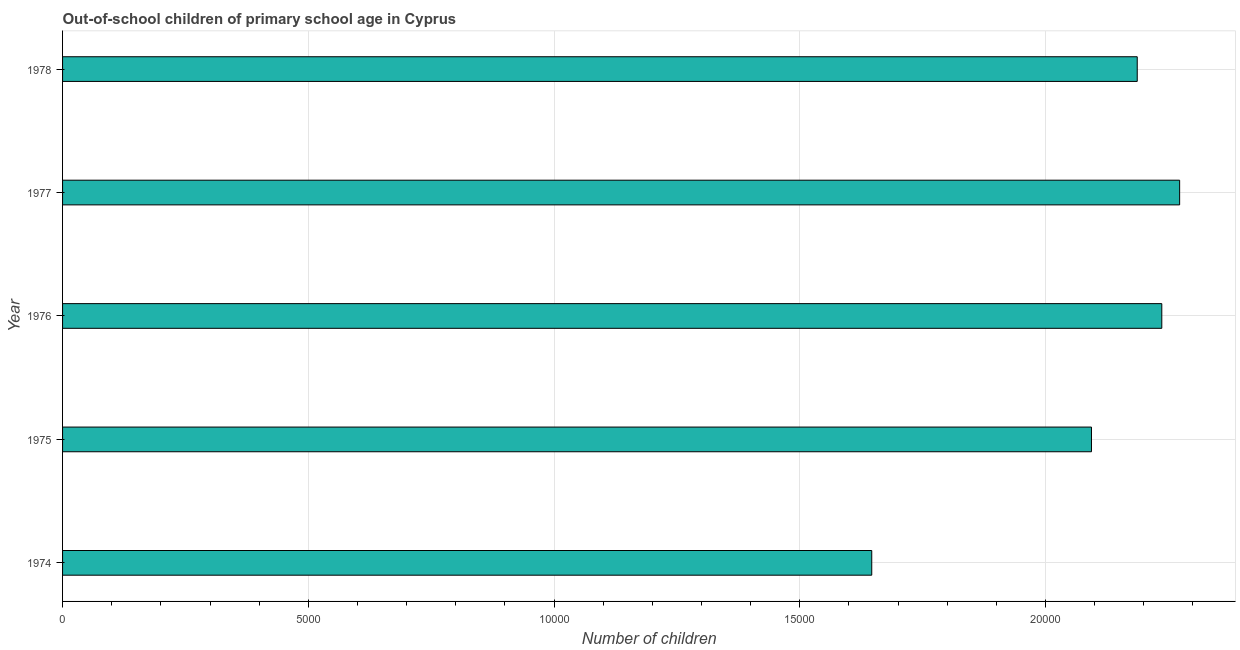What is the title of the graph?
Make the answer very short. Out-of-school children of primary school age in Cyprus. What is the label or title of the X-axis?
Give a very brief answer. Number of children. What is the number of out-of-school children in 1978?
Keep it short and to the point. 2.19e+04. Across all years, what is the maximum number of out-of-school children?
Keep it short and to the point. 2.27e+04. Across all years, what is the minimum number of out-of-school children?
Provide a short and direct response. 1.65e+04. In which year was the number of out-of-school children minimum?
Your answer should be very brief. 1974. What is the sum of the number of out-of-school children?
Offer a terse response. 1.04e+05. What is the difference between the number of out-of-school children in 1974 and 1975?
Your answer should be compact. -4471. What is the average number of out-of-school children per year?
Offer a terse response. 2.09e+04. What is the median number of out-of-school children?
Provide a succinct answer. 2.19e+04. Do a majority of the years between 1974 and 1978 (inclusive) have number of out-of-school children greater than 11000 ?
Your response must be concise. Yes. What is the ratio of the number of out-of-school children in 1975 to that in 1977?
Make the answer very short. 0.92. Is the number of out-of-school children in 1976 less than that in 1978?
Offer a terse response. No. Is the difference between the number of out-of-school children in 1974 and 1975 greater than the difference between any two years?
Your answer should be very brief. No. What is the difference between the highest and the second highest number of out-of-school children?
Make the answer very short. 363. What is the difference between the highest and the lowest number of out-of-school children?
Keep it short and to the point. 6265. In how many years, is the number of out-of-school children greater than the average number of out-of-school children taken over all years?
Make the answer very short. 4. How many bars are there?
Give a very brief answer. 5. Are the values on the major ticks of X-axis written in scientific E-notation?
Your answer should be compact. No. What is the Number of children in 1974?
Keep it short and to the point. 1.65e+04. What is the Number of children of 1975?
Your response must be concise. 2.09e+04. What is the Number of children of 1976?
Your answer should be very brief. 2.24e+04. What is the Number of children in 1977?
Ensure brevity in your answer.  2.27e+04. What is the Number of children in 1978?
Make the answer very short. 2.19e+04. What is the difference between the Number of children in 1974 and 1975?
Offer a terse response. -4471. What is the difference between the Number of children in 1974 and 1976?
Provide a succinct answer. -5902. What is the difference between the Number of children in 1974 and 1977?
Make the answer very short. -6265. What is the difference between the Number of children in 1974 and 1978?
Keep it short and to the point. -5402. What is the difference between the Number of children in 1975 and 1976?
Your answer should be compact. -1431. What is the difference between the Number of children in 1975 and 1977?
Make the answer very short. -1794. What is the difference between the Number of children in 1975 and 1978?
Your answer should be compact. -931. What is the difference between the Number of children in 1976 and 1977?
Provide a succinct answer. -363. What is the difference between the Number of children in 1976 and 1978?
Provide a succinct answer. 500. What is the difference between the Number of children in 1977 and 1978?
Keep it short and to the point. 863. What is the ratio of the Number of children in 1974 to that in 1975?
Your answer should be compact. 0.79. What is the ratio of the Number of children in 1974 to that in 1976?
Ensure brevity in your answer.  0.74. What is the ratio of the Number of children in 1974 to that in 1977?
Provide a succinct answer. 0.72. What is the ratio of the Number of children in 1974 to that in 1978?
Ensure brevity in your answer.  0.75. What is the ratio of the Number of children in 1975 to that in 1976?
Give a very brief answer. 0.94. What is the ratio of the Number of children in 1975 to that in 1977?
Keep it short and to the point. 0.92. What is the ratio of the Number of children in 1975 to that in 1978?
Your answer should be very brief. 0.96. What is the ratio of the Number of children in 1976 to that in 1977?
Keep it short and to the point. 0.98. What is the ratio of the Number of children in 1976 to that in 1978?
Give a very brief answer. 1.02. What is the ratio of the Number of children in 1977 to that in 1978?
Offer a terse response. 1.04. 